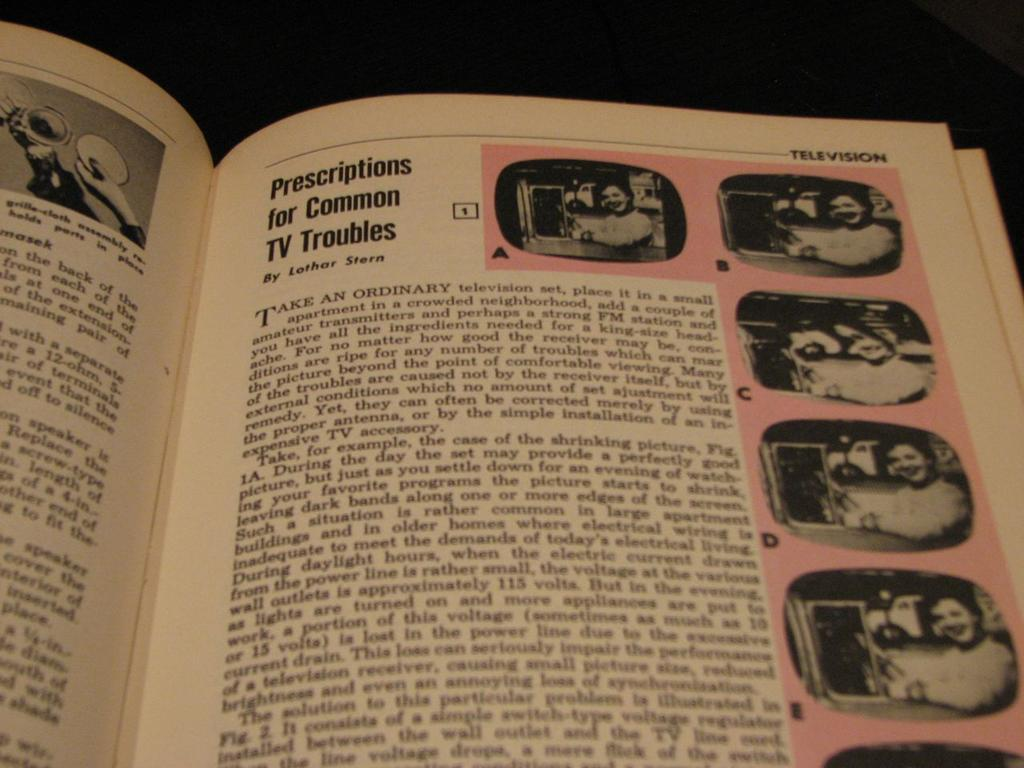Provide a one-sentence caption for the provided image. A book is open to a page about solving TV troubles with images of a woman by a tv on the edge of the page. 